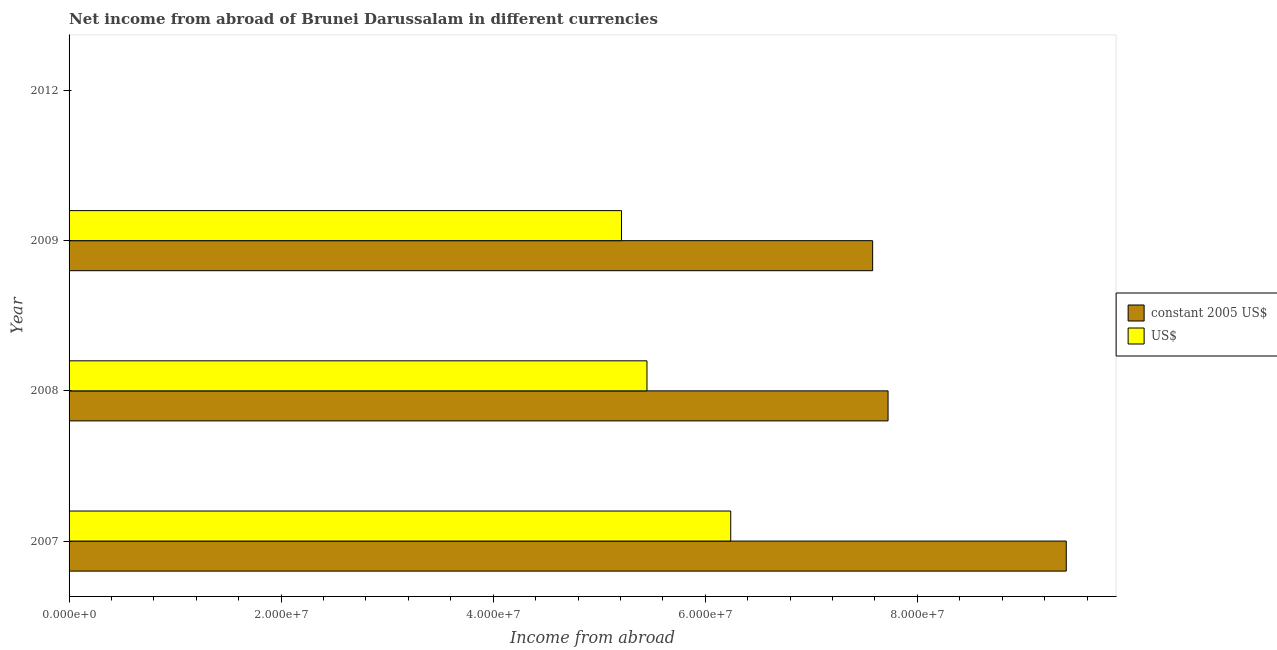How many different coloured bars are there?
Make the answer very short. 2. Are the number of bars per tick equal to the number of legend labels?
Provide a succinct answer. No. Are the number of bars on each tick of the Y-axis equal?
Provide a short and direct response. No. How many bars are there on the 1st tick from the top?
Provide a short and direct response. 0. How many bars are there on the 4th tick from the bottom?
Keep it short and to the point. 0. What is the label of the 1st group of bars from the top?
Give a very brief answer. 2012. In how many cases, is the number of bars for a given year not equal to the number of legend labels?
Your answer should be compact. 1. What is the income from abroad in us$ in 2012?
Keep it short and to the point. 0. Across all years, what is the maximum income from abroad in constant 2005 us$?
Offer a terse response. 9.40e+07. In which year was the income from abroad in constant 2005 us$ maximum?
Your answer should be compact. 2007. What is the total income from abroad in constant 2005 us$ in the graph?
Give a very brief answer. 2.47e+08. What is the difference between the income from abroad in constant 2005 us$ in 2008 and that in 2009?
Make the answer very short. 1.45e+06. What is the difference between the income from abroad in constant 2005 us$ in 2009 and the income from abroad in us$ in 2012?
Your answer should be very brief. 7.58e+07. What is the average income from abroad in us$ per year?
Your answer should be compact. 4.23e+07. In the year 2009, what is the difference between the income from abroad in constant 2005 us$ and income from abroad in us$?
Offer a very short reply. 2.37e+07. What is the ratio of the income from abroad in constant 2005 us$ in 2007 to that in 2009?
Ensure brevity in your answer.  1.24. Is the income from abroad in us$ in 2007 less than that in 2008?
Your response must be concise. No. What is the difference between the highest and the second highest income from abroad in us$?
Keep it short and to the point. 7.90e+06. What is the difference between the highest and the lowest income from abroad in us$?
Your answer should be compact. 6.24e+07. How many bars are there?
Give a very brief answer. 6. What is the difference between two consecutive major ticks on the X-axis?
Your response must be concise. 2.00e+07. Are the values on the major ticks of X-axis written in scientific E-notation?
Your response must be concise. Yes. Does the graph contain grids?
Ensure brevity in your answer.  No. How many legend labels are there?
Provide a succinct answer. 2. What is the title of the graph?
Your response must be concise. Net income from abroad of Brunei Darussalam in different currencies. Does "Register a property" appear as one of the legend labels in the graph?
Give a very brief answer. No. What is the label or title of the X-axis?
Offer a very short reply. Income from abroad. What is the Income from abroad of constant 2005 US$ in 2007?
Provide a short and direct response. 9.40e+07. What is the Income from abroad of US$ in 2007?
Provide a short and direct response. 6.24e+07. What is the Income from abroad in constant 2005 US$ in 2008?
Ensure brevity in your answer.  7.72e+07. What is the Income from abroad of US$ in 2008?
Keep it short and to the point. 5.45e+07. What is the Income from abroad in constant 2005 US$ in 2009?
Keep it short and to the point. 7.58e+07. What is the Income from abroad of US$ in 2009?
Your response must be concise. 5.21e+07. Across all years, what is the maximum Income from abroad of constant 2005 US$?
Your answer should be compact. 9.40e+07. Across all years, what is the maximum Income from abroad in US$?
Your answer should be very brief. 6.24e+07. What is the total Income from abroad in constant 2005 US$ in the graph?
Provide a succinct answer. 2.47e+08. What is the total Income from abroad of US$ in the graph?
Your response must be concise. 1.69e+08. What is the difference between the Income from abroad in constant 2005 US$ in 2007 and that in 2008?
Give a very brief answer. 1.68e+07. What is the difference between the Income from abroad of US$ in 2007 and that in 2008?
Keep it short and to the point. 7.90e+06. What is the difference between the Income from abroad in constant 2005 US$ in 2007 and that in 2009?
Offer a very short reply. 1.83e+07. What is the difference between the Income from abroad of US$ in 2007 and that in 2009?
Provide a short and direct response. 1.03e+07. What is the difference between the Income from abroad in constant 2005 US$ in 2008 and that in 2009?
Keep it short and to the point. 1.45e+06. What is the difference between the Income from abroad in US$ in 2008 and that in 2009?
Your answer should be very brief. 2.40e+06. What is the difference between the Income from abroad of constant 2005 US$ in 2007 and the Income from abroad of US$ in 2008?
Provide a short and direct response. 3.95e+07. What is the difference between the Income from abroad of constant 2005 US$ in 2007 and the Income from abroad of US$ in 2009?
Offer a terse response. 4.19e+07. What is the difference between the Income from abroad in constant 2005 US$ in 2008 and the Income from abroad in US$ in 2009?
Offer a terse response. 2.51e+07. What is the average Income from abroad in constant 2005 US$ per year?
Ensure brevity in your answer.  6.18e+07. What is the average Income from abroad in US$ per year?
Give a very brief answer. 4.23e+07. In the year 2007, what is the difference between the Income from abroad of constant 2005 US$ and Income from abroad of US$?
Make the answer very short. 3.16e+07. In the year 2008, what is the difference between the Income from abroad in constant 2005 US$ and Income from abroad in US$?
Your answer should be compact. 2.27e+07. In the year 2009, what is the difference between the Income from abroad in constant 2005 US$ and Income from abroad in US$?
Provide a short and direct response. 2.37e+07. What is the ratio of the Income from abroad in constant 2005 US$ in 2007 to that in 2008?
Provide a short and direct response. 1.22. What is the ratio of the Income from abroad of US$ in 2007 to that in 2008?
Offer a terse response. 1.15. What is the ratio of the Income from abroad in constant 2005 US$ in 2007 to that in 2009?
Offer a terse response. 1.24. What is the ratio of the Income from abroad in US$ in 2007 to that in 2009?
Keep it short and to the point. 1.2. What is the ratio of the Income from abroad of constant 2005 US$ in 2008 to that in 2009?
Your response must be concise. 1.02. What is the ratio of the Income from abroad in US$ in 2008 to that in 2009?
Keep it short and to the point. 1.05. What is the difference between the highest and the second highest Income from abroad of constant 2005 US$?
Offer a terse response. 1.68e+07. What is the difference between the highest and the second highest Income from abroad in US$?
Provide a short and direct response. 7.90e+06. What is the difference between the highest and the lowest Income from abroad of constant 2005 US$?
Provide a short and direct response. 9.40e+07. What is the difference between the highest and the lowest Income from abroad of US$?
Your response must be concise. 6.24e+07. 